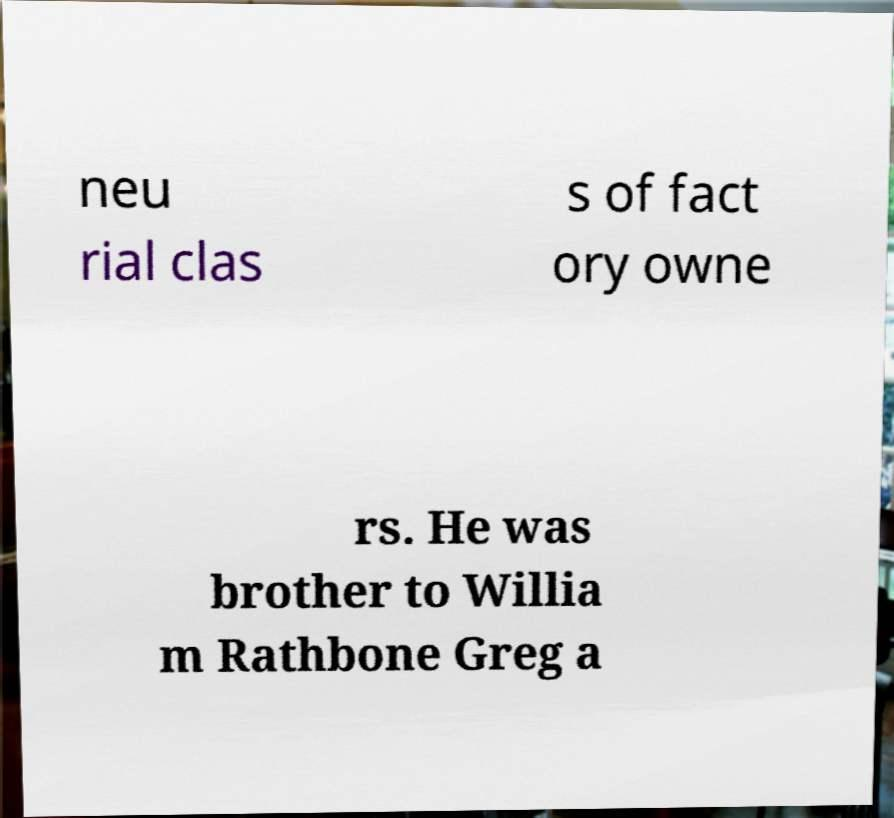Please read and relay the text visible in this image. What does it say? neu rial clas s of fact ory owne rs. He was brother to Willia m Rathbone Greg a 